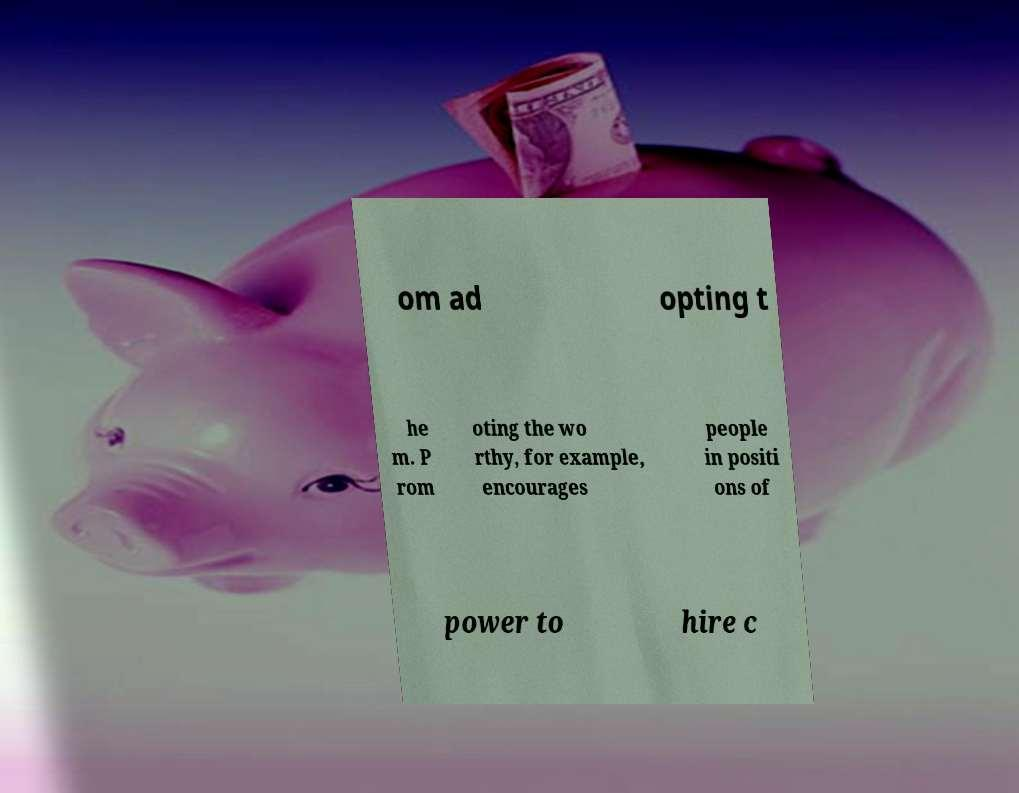I need the written content from this picture converted into text. Can you do that? om ad opting t he m. P rom oting the wo rthy, for example, encourages people in positi ons of power to hire c 